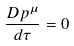<formula> <loc_0><loc_0><loc_500><loc_500>\frac { D p ^ { \mu } } { d \tau } = 0</formula> 